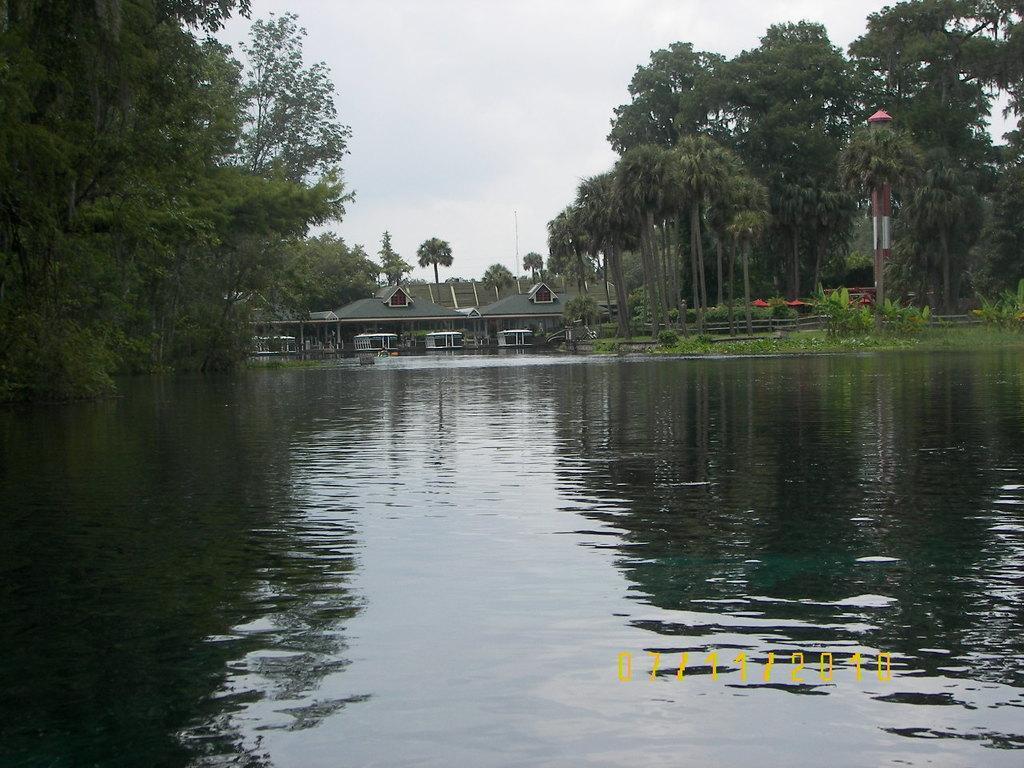Could you give a brief overview of what you see in this image? In this picture I can see the water. I can see the house. I can see wooden fence. I can see trees. I can see clouds in the sky. 